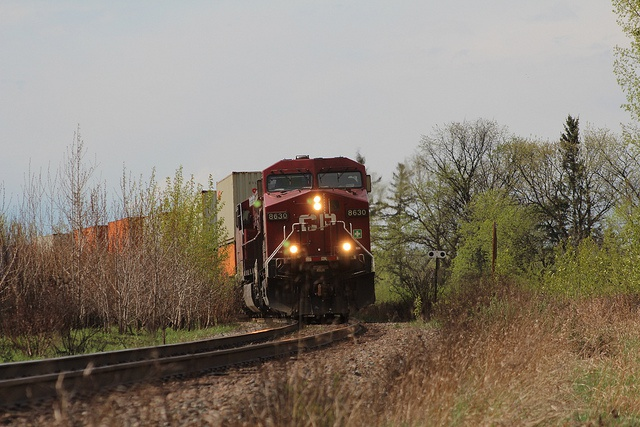Describe the objects in this image and their specific colors. I can see a train in lightgray, black, maroon, and gray tones in this image. 